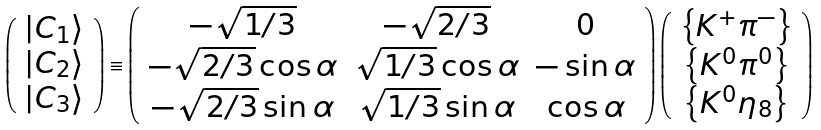<formula> <loc_0><loc_0><loc_500><loc_500>\left ( \begin{array} { c } { { \left | C _ { 1 } \right \rangle } } \\ { { \left | C _ { 2 } \right \rangle } } \\ { { \left | C _ { 3 } \right \rangle } } \end{array} \right ) \equiv \left ( \begin{array} { c c c } { { - \sqrt { 1 / 3 } } } & { { - \sqrt { 2 / 3 } } } & { 0 } \\ { { - \sqrt { 2 / 3 } \cos \alpha } } & { { \sqrt { 1 / 3 } \cos \alpha } } & { - \sin \alpha } \\ { { - \sqrt { 2 / 3 } \sin \alpha } } & { { \sqrt { 1 / 3 } \sin \alpha } } & { \cos \alpha } \end{array} \right ) \left ( \begin{array} { c } { { \left \{ K ^ { + } \pi ^ { - } \right \} } } \\ { { \left \{ K ^ { 0 } \pi ^ { 0 } \right \} } } \\ { { \left \{ K ^ { 0 } \eta _ { 8 } \right \} } } \end{array} \right )</formula> 